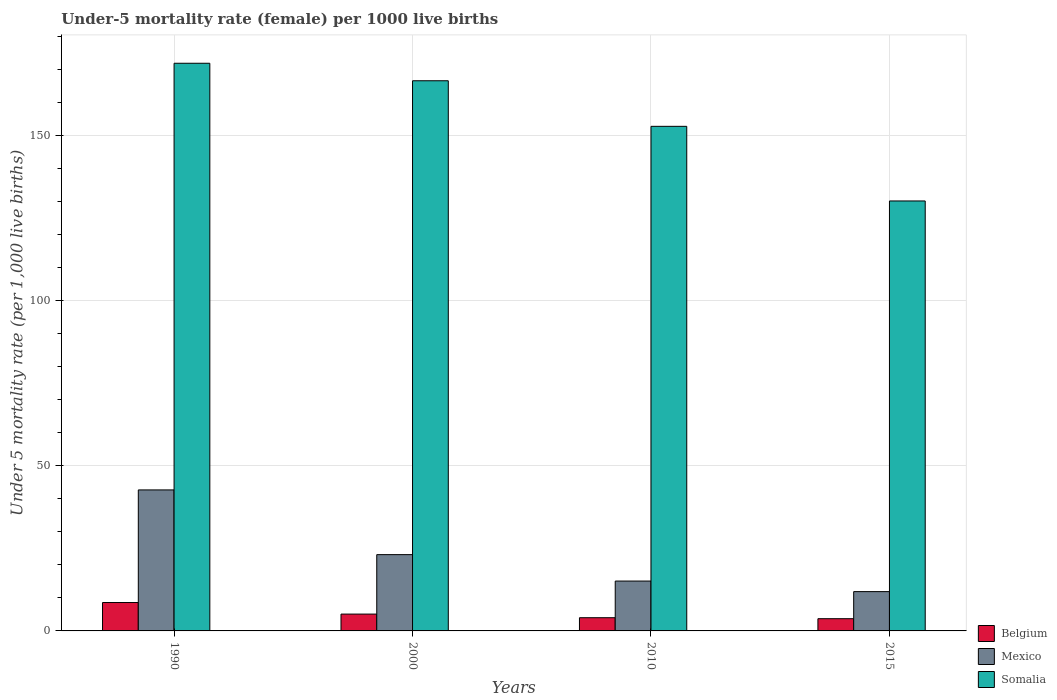Are the number of bars per tick equal to the number of legend labels?
Offer a very short reply. Yes. What is the label of the 4th group of bars from the left?
Your answer should be very brief. 2015. In how many cases, is the number of bars for a given year not equal to the number of legend labels?
Ensure brevity in your answer.  0. Across all years, what is the maximum under-five mortality rate in Somalia?
Offer a very short reply. 171.9. In which year was the under-five mortality rate in Somalia maximum?
Provide a short and direct response. 1990. In which year was the under-five mortality rate in Somalia minimum?
Your answer should be very brief. 2015. What is the total under-five mortality rate in Belgium in the graph?
Make the answer very short. 21.4. What is the difference between the under-five mortality rate in Mexico in 2000 and that in 2015?
Ensure brevity in your answer.  11.2. What is the difference between the under-five mortality rate in Somalia in 2010 and the under-five mortality rate in Mexico in 2015?
Provide a short and direct response. 140.9. What is the average under-five mortality rate in Belgium per year?
Your answer should be very brief. 5.35. In the year 2000, what is the difference between the under-five mortality rate in Mexico and under-five mortality rate in Belgium?
Make the answer very short. 18. What is the ratio of the under-five mortality rate in Belgium in 2000 to that in 2010?
Your answer should be compact. 1.27. Is the under-five mortality rate in Somalia in 2010 less than that in 2015?
Offer a terse response. No. Is the difference between the under-five mortality rate in Mexico in 2000 and 2010 greater than the difference between the under-five mortality rate in Belgium in 2000 and 2010?
Provide a succinct answer. Yes. What is the difference between the highest and the second highest under-five mortality rate in Mexico?
Make the answer very short. 19.6. What is the difference between the highest and the lowest under-five mortality rate in Somalia?
Give a very brief answer. 41.7. In how many years, is the under-five mortality rate in Mexico greater than the average under-five mortality rate in Mexico taken over all years?
Make the answer very short. 1. Is the sum of the under-five mortality rate in Belgium in 1990 and 2000 greater than the maximum under-five mortality rate in Somalia across all years?
Your answer should be very brief. No. What does the 1st bar from the left in 2000 represents?
Offer a very short reply. Belgium. What does the 2nd bar from the right in 1990 represents?
Give a very brief answer. Mexico. How many years are there in the graph?
Ensure brevity in your answer.  4. Are the values on the major ticks of Y-axis written in scientific E-notation?
Your response must be concise. No. Where does the legend appear in the graph?
Provide a succinct answer. Bottom right. How many legend labels are there?
Ensure brevity in your answer.  3. How are the legend labels stacked?
Your answer should be compact. Vertical. What is the title of the graph?
Make the answer very short. Under-5 mortality rate (female) per 1000 live births. Does "Lower middle income" appear as one of the legend labels in the graph?
Offer a terse response. No. What is the label or title of the Y-axis?
Provide a succinct answer. Under 5 mortality rate (per 1,0 live births). What is the Under 5 mortality rate (per 1,000 live births) of Belgium in 1990?
Provide a short and direct response. 8.6. What is the Under 5 mortality rate (per 1,000 live births) of Mexico in 1990?
Offer a very short reply. 42.7. What is the Under 5 mortality rate (per 1,000 live births) in Somalia in 1990?
Provide a short and direct response. 171.9. What is the Under 5 mortality rate (per 1,000 live births) of Mexico in 2000?
Your response must be concise. 23.1. What is the Under 5 mortality rate (per 1,000 live births) of Somalia in 2000?
Your answer should be compact. 166.6. What is the Under 5 mortality rate (per 1,000 live births) in Belgium in 2010?
Provide a succinct answer. 4. What is the Under 5 mortality rate (per 1,000 live births) in Somalia in 2010?
Offer a terse response. 152.8. What is the Under 5 mortality rate (per 1,000 live births) in Belgium in 2015?
Give a very brief answer. 3.7. What is the Under 5 mortality rate (per 1,000 live births) of Mexico in 2015?
Ensure brevity in your answer.  11.9. What is the Under 5 mortality rate (per 1,000 live births) in Somalia in 2015?
Your answer should be compact. 130.2. Across all years, what is the maximum Under 5 mortality rate (per 1,000 live births) in Belgium?
Keep it short and to the point. 8.6. Across all years, what is the maximum Under 5 mortality rate (per 1,000 live births) of Mexico?
Provide a short and direct response. 42.7. Across all years, what is the maximum Under 5 mortality rate (per 1,000 live births) in Somalia?
Provide a succinct answer. 171.9. Across all years, what is the minimum Under 5 mortality rate (per 1,000 live births) of Somalia?
Your response must be concise. 130.2. What is the total Under 5 mortality rate (per 1,000 live births) of Belgium in the graph?
Your response must be concise. 21.4. What is the total Under 5 mortality rate (per 1,000 live births) of Mexico in the graph?
Keep it short and to the point. 92.8. What is the total Under 5 mortality rate (per 1,000 live births) of Somalia in the graph?
Make the answer very short. 621.5. What is the difference between the Under 5 mortality rate (per 1,000 live births) of Belgium in 1990 and that in 2000?
Your response must be concise. 3.5. What is the difference between the Under 5 mortality rate (per 1,000 live births) of Mexico in 1990 and that in 2000?
Make the answer very short. 19.6. What is the difference between the Under 5 mortality rate (per 1,000 live births) of Belgium in 1990 and that in 2010?
Give a very brief answer. 4.6. What is the difference between the Under 5 mortality rate (per 1,000 live births) in Mexico in 1990 and that in 2010?
Offer a very short reply. 27.6. What is the difference between the Under 5 mortality rate (per 1,000 live births) in Mexico in 1990 and that in 2015?
Your response must be concise. 30.8. What is the difference between the Under 5 mortality rate (per 1,000 live births) in Somalia in 1990 and that in 2015?
Your answer should be compact. 41.7. What is the difference between the Under 5 mortality rate (per 1,000 live births) of Mexico in 2000 and that in 2010?
Your response must be concise. 8. What is the difference between the Under 5 mortality rate (per 1,000 live births) of Belgium in 2000 and that in 2015?
Offer a terse response. 1.4. What is the difference between the Under 5 mortality rate (per 1,000 live births) in Mexico in 2000 and that in 2015?
Keep it short and to the point. 11.2. What is the difference between the Under 5 mortality rate (per 1,000 live births) in Somalia in 2000 and that in 2015?
Your answer should be very brief. 36.4. What is the difference between the Under 5 mortality rate (per 1,000 live births) in Belgium in 2010 and that in 2015?
Your response must be concise. 0.3. What is the difference between the Under 5 mortality rate (per 1,000 live births) of Mexico in 2010 and that in 2015?
Your answer should be very brief. 3.2. What is the difference between the Under 5 mortality rate (per 1,000 live births) in Somalia in 2010 and that in 2015?
Provide a short and direct response. 22.6. What is the difference between the Under 5 mortality rate (per 1,000 live births) in Belgium in 1990 and the Under 5 mortality rate (per 1,000 live births) in Somalia in 2000?
Keep it short and to the point. -158. What is the difference between the Under 5 mortality rate (per 1,000 live births) of Mexico in 1990 and the Under 5 mortality rate (per 1,000 live births) of Somalia in 2000?
Give a very brief answer. -123.9. What is the difference between the Under 5 mortality rate (per 1,000 live births) in Belgium in 1990 and the Under 5 mortality rate (per 1,000 live births) in Somalia in 2010?
Your answer should be very brief. -144.2. What is the difference between the Under 5 mortality rate (per 1,000 live births) in Mexico in 1990 and the Under 5 mortality rate (per 1,000 live births) in Somalia in 2010?
Ensure brevity in your answer.  -110.1. What is the difference between the Under 5 mortality rate (per 1,000 live births) in Belgium in 1990 and the Under 5 mortality rate (per 1,000 live births) in Somalia in 2015?
Offer a very short reply. -121.6. What is the difference between the Under 5 mortality rate (per 1,000 live births) in Mexico in 1990 and the Under 5 mortality rate (per 1,000 live births) in Somalia in 2015?
Your answer should be very brief. -87.5. What is the difference between the Under 5 mortality rate (per 1,000 live births) in Belgium in 2000 and the Under 5 mortality rate (per 1,000 live births) in Somalia in 2010?
Offer a terse response. -147.7. What is the difference between the Under 5 mortality rate (per 1,000 live births) in Mexico in 2000 and the Under 5 mortality rate (per 1,000 live births) in Somalia in 2010?
Provide a short and direct response. -129.7. What is the difference between the Under 5 mortality rate (per 1,000 live births) of Belgium in 2000 and the Under 5 mortality rate (per 1,000 live births) of Somalia in 2015?
Provide a succinct answer. -125.1. What is the difference between the Under 5 mortality rate (per 1,000 live births) of Mexico in 2000 and the Under 5 mortality rate (per 1,000 live births) of Somalia in 2015?
Offer a terse response. -107.1. What is the difference between the Under 5 mortality rate (per 1,000 live births) of Belgium in 2010 and the Under 5 mortality rate (per 1,000 live births) of Somalia in 2015?
Offer a very short reply. -126.2. What is the difference between the Under 5 mortality rate (per 1,000 live births) in Mexico in 2010 and the Under 5 mortality rate (per 1,000 live births) in Somalia in 2015?
Ensure brevity in your answer.  -115.1. What is the average Under 5 mortality rate (per 1,000 live births) of Belgium per year?
Offer a very short reply. 5.35. What is the average Under 5 mortality rate (per 1,000 live births) in Mexico per year?
Give a very brief answer. 23.2. What is the average Under 5 mortality rate (per 1,000 live births) in Somalia per year?
Offer a very short reply. 155.38. In the year 1990, what is the difference between the Under 5 mortality rate (per 1,000 live births) in Belgium and Under 5 mortality rate (per 1,000 live births) in Mexico?
Make the answer very short. -34.1. In the year 1990, what is the difference between the Under 5 mortality rate (per 1,000 live births) in Belgium and Under 5 mortality rate (per 1,000 live births) in Somalia?
Give a very brief answer. -163.3. In the year 1990, what is the difference between the Under 5 mortality rate (per 1,000 live births) of Mexico and Under 5 mortality rate (per 1,000 live births) of Somalia?
Keep it short and to the point. -129.2. In the year 2000, what is the difference between the Under 5 mortality rate (per 1,000 live births) of Belgium and Under 5 mortality rate (per 1,000 live births) of Mexico?
Ensure brevity in your answer.  -18. In the year 2000, what is the difference between the Under 5 mortality rate (per 1,000 live births) in Belgium and Under 5 mortality rate (per 1,000 live births) in Somalia?
Give a very brief answer. -161.5. In the year 2000, what is the difference between the Under 5 mortality rate (per 1,000 live births) in Mexico and Under 5 mortality rate (per 1,000 live births) in Somalia?
Offer a terse response. -143.5. In the year 2010, what is the difference between the Under 5 mortality rate (per 1,000 live births) in Belgium and Under 5 mortality rate (per 1,000 live births) in Mexico?
Ensure brevity in your answer.  -11.1. In the year 2010, what is the difference between the Under 5 mortality rate (per 1,000 live births) of Belgium and Under 5 mortality rate (per 1,000 live births) of Somalia?
Ensure brevity in your answer.  -148.8. In the year 2010, what is the difference between the Under 5 mortality rate (per 1,000 live births) in Mexico and Under 5 mortality rate (per 1,000 live births) in Somalia?
Your answer should be very brief. -137.7. In the year 2015, what is the difference between the Under 5 mortality rate (per 1,000 live births) in Belgium and Under 5 mortality rate (per 1,000 live births) in Somalia?
Offer a very short reply. -126.5. In the year 2015, what is the difference between the Under 5 mortality rate (per 1,000 live births) in Mexico and Under 5 mortality rate (per 1,000 live births) in Somalia?
Keep it short and to the point. -118.3. What is the ratio of the Under 5 mortality rate (per 1,000 live births) in Belgium in 1990 to that in 2000?
Your answer should be very brief. 1.69. What is the ratio of the Under 5 mortality rate (per 1,000 live births) in Mexico in 1990 to that in 2000?
Make the answer very short. 1.85. What is the ratio of the Under 5 mortality rate (per 1,000 live births) in Somalia in 1990 to that in 2000?
Make the answer very short. 1.03. What is the ratio of the Under 5 mortality rate (per 1,000 live births) of Belgium in 1990 to that in 2010?
Give a very brief answer. 2.15. What is the ratio of the Under 5 mortality rate (per 1,000 live births) in Mexico in 1990 to that in 2010?
Provide a succinct answer. 2.83. What is the ratio of the Under 5 mortality rate (per 1,000 live births) in Somalia in 1990 to that in 2010?
Offer a terse response. 1.12. What is the ratio of the Under 5 mortality rate (per 1,000 live births) in Belgium in 1990 to that in 2015?
Give a very brief answer. 2.32. What is the ratio of the Under 5 mortality rate (per 1,000 live births) in Mexico in 1990 to that in 2015?
Offer a very short reply. 3.59. What is the ratio of the Under 5 mortality rate (per 1,000 live births) of Somalia in 1990 to that in 2015?
Keep it short and to the point. 1.32. What is the ratio of the Under 5 mortality rate (per 1,000 live births) in Belgium in 2000 to that in 2010?
Provide a succinct answer. 1.27. What is the ratio of the Under 5 mortality rate (per 1,000 live births) of Mexico in 2000 to that in 2010?
Your response must be concise. 1.53. What is the ratio of the Under 5 mortality rate (per 1,000 live births) of Somalia in 2000 to that in 2010?
Keep it short and to the point. 1.09. What is the ratio of the Under 5 mortality rate (per 1,000 live births) in Belgium in 2000 to that in 2015?
Make the answer very short. 1.38. What is the ratio of the Under 5 mortality rate (per 1,000 live births) in Mexico in 2000 to that in 2015?
Provide a short and direct response. 1.94. What is the ratio of the Under 5 mortality rate (per 1,000 live births) in Somalia in 2000 to that in 2015?
Your answer should be compact. 1.28. What is the ratio of the Under 5 mortality rate (per 1,000 live births) in Belgium in 2010 to that in 2015?
Keep it short and to the point. 1.08. What is the ratio of the Under 5 mortality rate (per 1,000 live births) of Mexico in 2010 to that in 2015?
Your response must be concise. 1.27. What is the ratio of the Under 5 mortality rate (per 1,000 live births) of Somalia in 2010 to that in 2015?
Ensure brevity in your answer.  1.17. What is the difference between the highest and the second highest Under 5 mortality rate (per 1,000 live births) in Mexico?
Offer a terse response. 19.6. What is the difference between the highest and the second highest Under 5 mortality rate (per 1,000 live births) in Somalia?
Your answer should be compact. 5.3. What is the difference between the highest and the lowest Under 5 mortality rate (per 1,000 live births) of Belgium?
Keep it short and to the point. 4.9. What is the difference between the highest and the lowest Under 5 mortality rate (per 1,000 live births) of Mexico?
Offer a very short reply. 30.8. What is the difference between the highest and the lowest Under 5 mortality rate (per 1,000 live births) of Somalia?
Give a very brief answer. 41.7. 